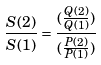<formula> <loc_0><loc_0><loc_500><loc_500>\frac { S ( 2 ) } { S ( 1 ) } = \frac { ( \frac { Q ( 2 ) } { Q ( 1 ) } ) } { ( \frac { P ( 2 ) } { P ( 1 ) } ) }</formula> 